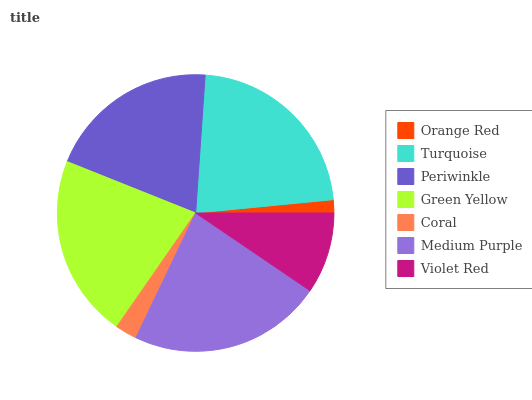Is Orange Red the minimum?
Answer yes or no. Yes. Is Medium Purple the maximum?
Answer yes or no. Yes. Is Turquoise the minimum?
Answer yes or no. No. Is Turquoise the maximum?
Answer yes or no. No. Is Turquoise greater than Orange Red?
Answer yes or no. Yes. Is Orange Red less than Turquoise?
Answer yes or no. Yes. Is Orange Red greater than Turquoise?
Answer yes or no. No. Is Turquoise less than Orange Red?
Answer yes or no. No. Is Periwinkle the high median?
Answer yes or no. Yes. Is Periwinkle the low median?
Answer yes or no. Yes. Is Violet Red the high median?
Answer yes or no. No. Is Orange Red the low median?
Answer yes or no. No. 